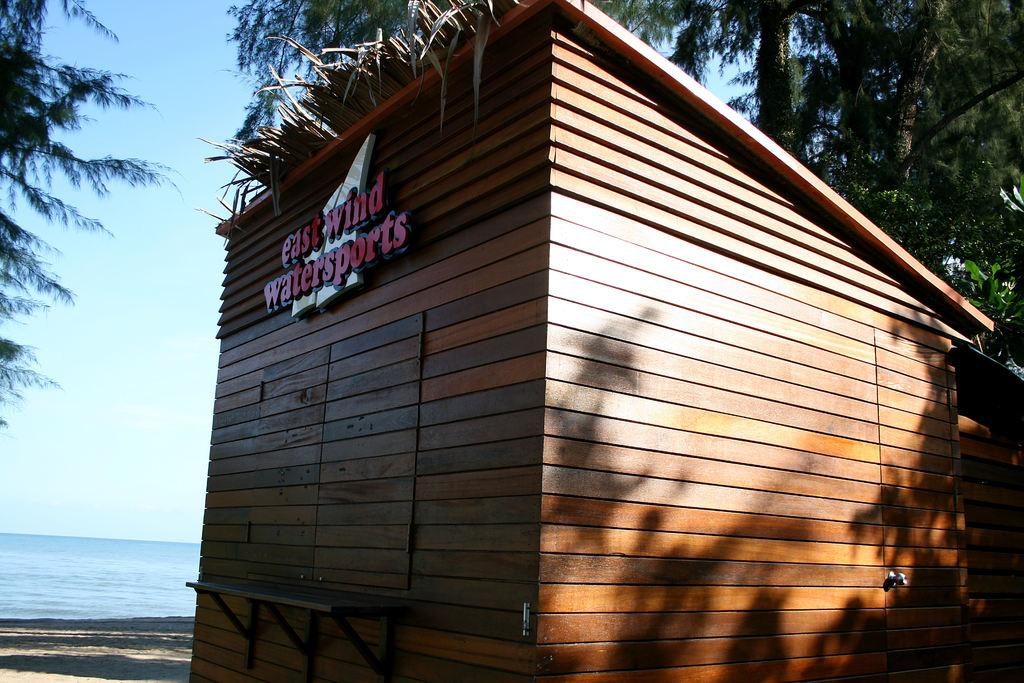What type of structure is present in the image? There is a house in the image. Are there any words or letters on the house? Yes, there is text on the house. What type of natural elements can be seen in the image? There are trees and water visible in the image. What is visible at the top of the image? The sky is visible at the top of the image. What type of beam is holding up the roof of the house in the image? There is no beam visible in the image, and the type of beam supporting the roof cannot be determined. Is the queen present in the image? There is no indication of a queen or any person in the image; it only features a house, trees, water, and the sky. 